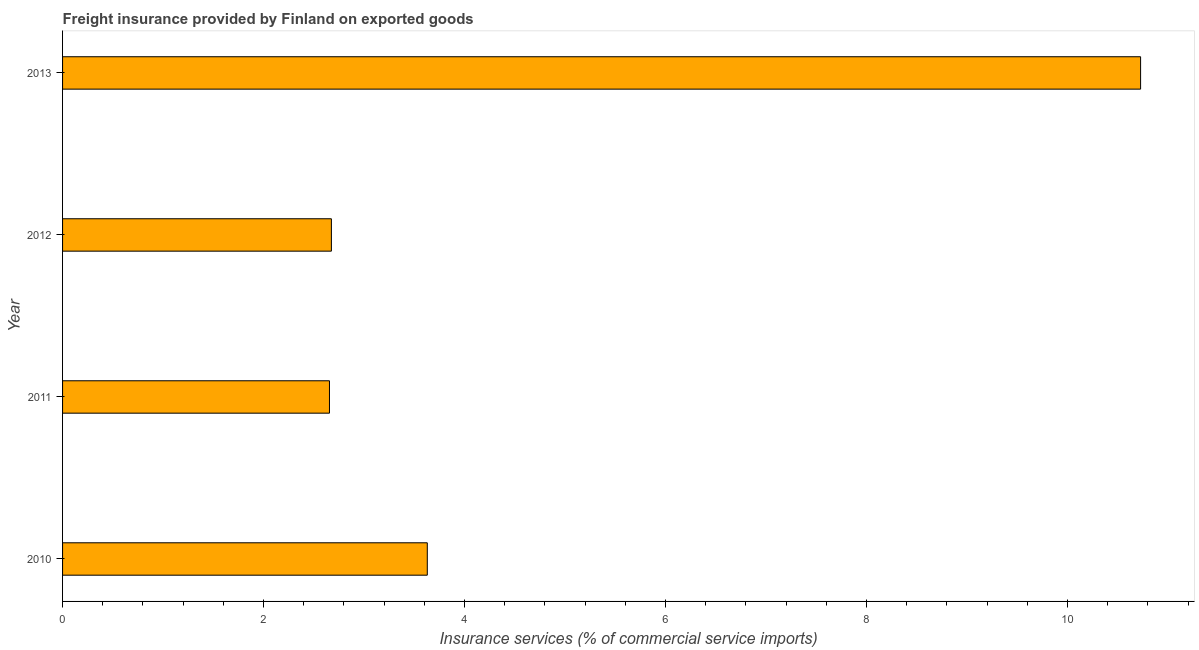Does the graph contain grids?
Make the answer very short. No. What is the title of the graph?
Keep it short and to the point. Freight insurance provided by Finland on exported goods . What is the label or title of the X-axis?
Offer a terse response. Insurance services (% of commercial service imports). What is the label or title of the Y-axis?
Your answer should be compact. Year. What is the freight insurance in 2012?
Keep it short and to the point. 2.68. Across all years, what is the maximum freight insurance?
Give a very brief answer. 10.73. Across all years, what is the minimum freight insurance?
Your answer should be compact. 2.66. In which year was the freight insurance minimum?
Your answer should be compact. 2011. What is the sum of the freight insurance?
Offer a very short reply. 19.69. What is the average freight insurance per year?
Offer a terse response. 4.92. What is the median freight insurance?
Your answer should be very brief. 3.15. In how many years, is the freight insurance greater than 8 %?
Offer a terse response. 1. What is the ratio of the freight insurance in 2011 to that in 2012?
Make the answer very short. 0.99. Is the freight insurance in 2012 less than that in 2013?
Provide a succinct answer. Yes. Is the difference between the freight insurance in 2010 and 2013 greater than the difference between any two years?
Ensure brevity in your answer.  No. What is the difference between the highest and the second highest freight insurance?
Your answer should be compact. 7.1. What is the difference between the highest and the lowest freight insurance?
Ensure brevity in your answer.  8.07. In how many years, is the freight insurance greater than the average freight insurance taken over all years?
Give a very brief answer. 1. How many bars are there?
Keep it short and to the point. 4. Are all the bars in the graph horizontal?
Make the answer very short. Yes. How many years are there in the graph?
Your response must be concise. 4. What is the Insurance services (% of commercial service imports) in 2010?
Provide a short and direct response. 3.63. What is the Insurance services (% of commercial service imports) in 2011?
Give a very brief answer. 2.66. What is the Insurance services (% of commercial service imports) of 2012?
Offer a terse response. 2.68. What is the Insurance services (% of commercial service imports) of 2013?
Ensure brevity in your answer.  10.73. What is the difference between the Insurance services (% of commercial service imports) in 2010 and 2011?
Keep it short and to the point. 0.97. What is the difference between the Insurance services (% of commercial service imports) in 2010 and 2012?
Keep it short and to the point. 0.95. What is the difference between the Insurance services (% of commercial service imports) in 2010 and 2013?
Keep it short and to the point. -7.1. What is the difference between the Insurance services (% of commercial service imports) in 2011 and 2012?
Offer a terse response. -0.02. What is the difference between the Insurance services (% of commercial service imports) in 2011 and 2013?
Give a very brief answer. -8.07. What is the difference between the Insurance services (% of commercial service imports) in 2012 and 2013?
Offer a terse response. -8.05. What is the ratio of the Insurance services (% of commercial service imports) in 2010 to that in 2011?
Keep it short and to the point. 1.37. What is the ratio of the Insurance services (% of commercial service imports) in 2010 to that in 2012?
Provide a short and direct response. 1.36. What is the ratio of the Insurance services (% of commercial service imports) in 2010 to that in 2013?
Your response must be concise. 0.34. What is the ratio of the Insurance services (% of commercial service imports) in 2011 to that in 2013?
Keep it short and to the point. 0.25. What is the ratio of the Insurance services (% of commercial service imports) in 2012 to that in 2013?
Provide a succinct answer. 0.25. 